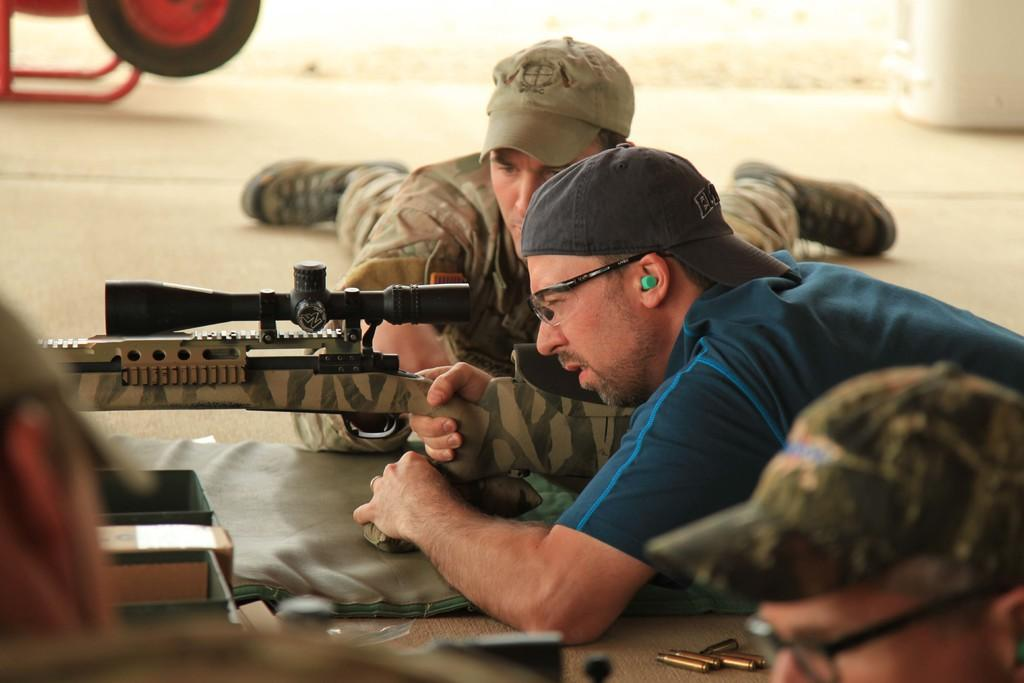How many people are in the image? There are three persons in the image. What are the persons doing in the image? The persons are lying on the floor. Can you describe any objects be seen in the hands of one of the persons? Yes, one person is holding a gun. What else can be seen on the floor besides the persons? There are boxes, cloth, and bullets on the floor. What time of day is it in the image? The time of day cannot be determined from the image. What type of work are the persons engaged in? There is no indication of work or a specific activity in the image. 